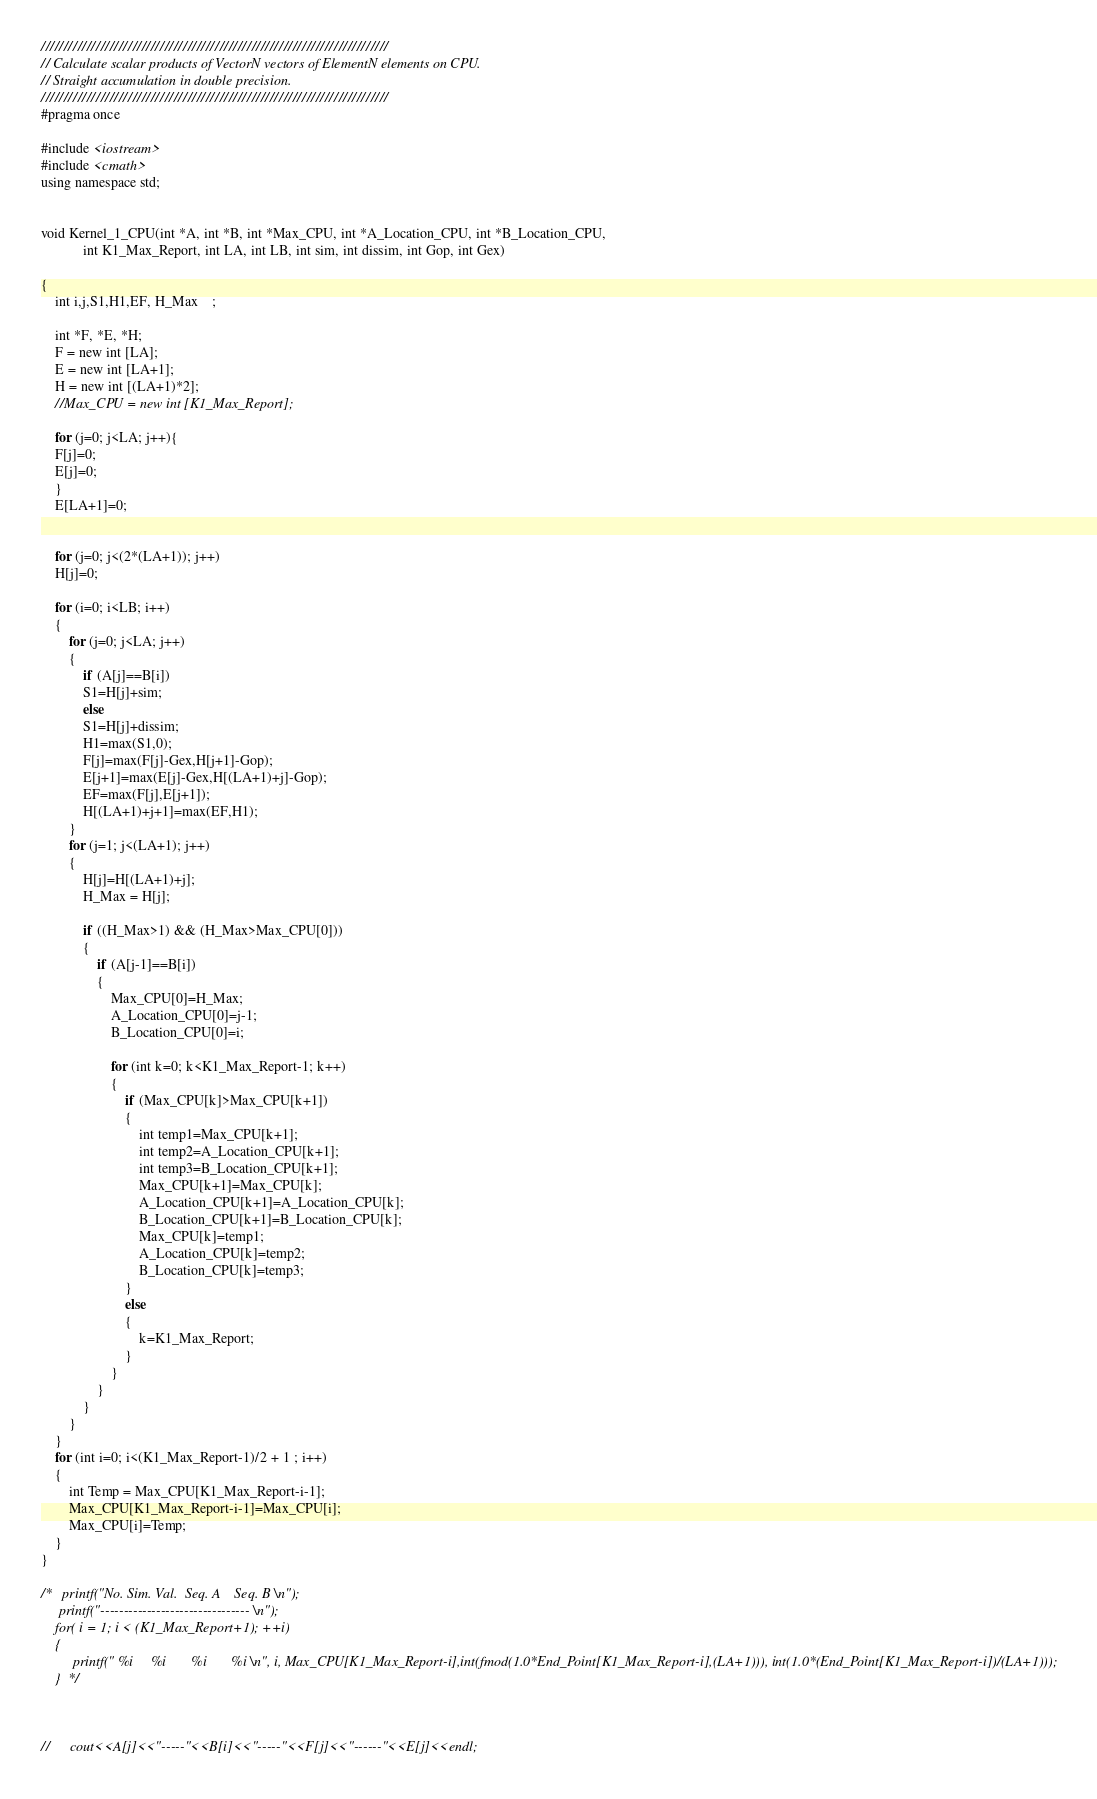Convert code to text. <code><loc_0><loc_0><loc_500><loc_500><_Cuda_>////////////////////////////////////////////////////////////////////////////
// Calculate scalar products of VectorN vectors of ElementN elements on CPU.
// Straight accumulation in double precision.
////////////////////////////////////////////////////////////////////////////
#pragma once

#include <iostream>
#include <cmath>
using namespace std;


void Kernel_1_CPU(int *A, int *B, int *Max_CPU, int *A_Location_CPU, int *B_Location_CPU, 
			int K1_Max_Report, int LA, int LB, int sim, int dissim, int Gop, int Gex)					  

{
	int i,j,S1,H1,EF, H_Max	;

	int *F, *E, *H;
	F = new int [LA];
	E = new int [LA+1];
	H = new int [(LA+1)*2];
	//Max_CPU = new int [K1_Max_Report];

	for (j=0; j<LA; j++){
	F[j]=0;
	E[j]=0;
	}
	E[LA+1]=0;


	for (j=0; j<(2*(LA+1)); j++)
	H[j]=0;

	for (i=0; i<LB; i++)
	{
		for (j=0; j<LA; j++)
		{
			if (A[j]==B[i])
			S1=H[j]+sim;
			else 
			S1=H[j]+dissim;
			H1=max(S1,0);
			F[j]=max(F[j]-Gex,H[j+1]-Gop);
			E[j+1]=max(E[j]-Gex,H[(LA+1)+j]-Gop);
			EF=max(F[j],E[j+1]);
			H[(LA+1)+j+1]=max(EF,H1);
		}
		for (j=1; j<(LA+1); j++)
		{
			H[j]=H[(LA+1)+j];
			H_Max = H[j];

			if ((H_Max>1) && (H_Max>Max_CPU[0]))
			{
				if (A[j-1]==B[i])
				{
					Max_CPU[0]=H_Max;
					A_Location_CPU[0]=j-1;
					B_Location_CPU[0]=i;

					for (int k=0; k<K1_Max_Report-1; k++)
					{
						if (Max_CPU[k]>Max_CPU[k+1])
						{		
							int temp1=Max_CPU[k+1];
							int temp2=A_Location_CPU[k+1];
							int temp3=B_Location_CPU[k+1];	
							Max_CPU[k+1]=Max_CPU[k];
							A_Location_CPU[k+1]=A_Location_CPU[k];
							B_Location_CPU[k+1]=B_Location_CPU[k];
							Max_CPU[k]=temp1;
							A_Location_CPU[k]=temp2;
							B_Location_CPU[k]=temp3;
						}
						else
						{
							k=K1_Max_Report;
						}
					}
				}
			}
		}
	}
	for (int i=0; i<(K1_Max_Report-1)/2 + 1 ; i++)
	{
		int Temp = Max_CPU[K1_Max_Report-i-1];
		Max_CPU[K1_Max_Report-i-1]=Max_CPU[i];
		Max_CPU[i]=Temp;
	}
}

/*	 printf("No. Sim. Val.  Seq. A    Seq. B \n");
	 printf("-------------------------------- \n");
    for( i = 1; i < (K1_Max_Report+1); ++i)     
    {
   		 printf(" %i     %i       %i       %i \n", i, Max_CPU[K1_Max_Report-i],int(fmod(1.0*End_Point[K1_Max_Report-i],(LA+1))), int(1.0*(End_Point[K1_Max_Report-i])/(LA+1)));
    }  */



//		cout<<A[j]<<"-----"<<B[i]<<"-----"<<F[j]<<"------"<<E[j]<<endl;	</code> 